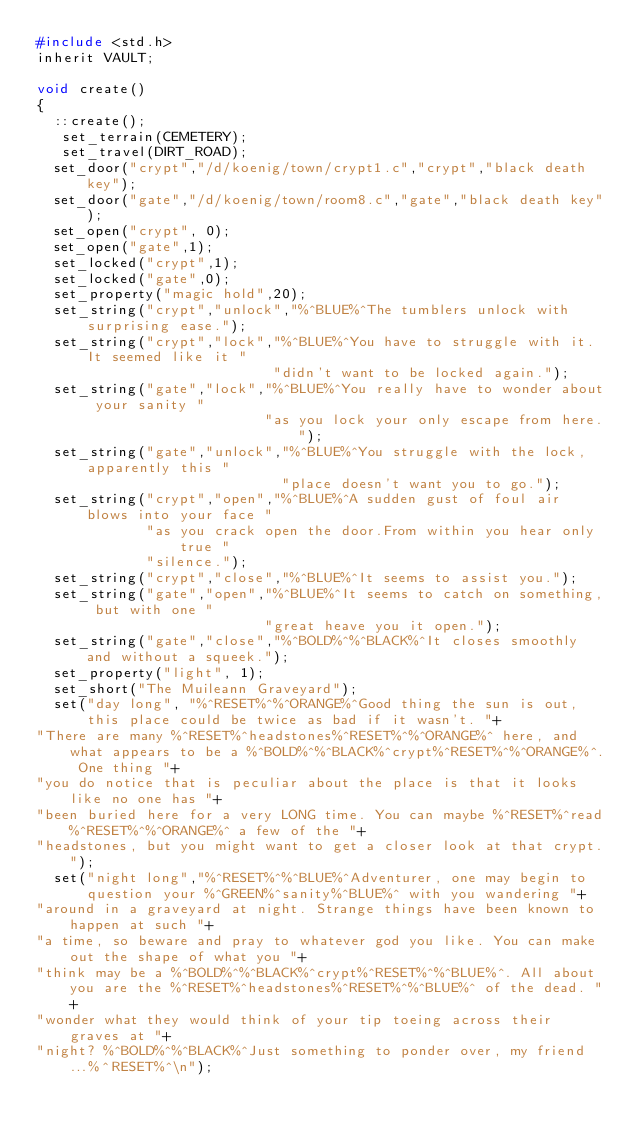Convert code to text. <code><loc_0><loc_0><loc_500><loc_500><_C_>#include <std.h>
inherit VAULT;

void create()
{
  ::create();
   set_terrain(CEMETERY);
   set_travel(DIRT_ROAD);
  set_door("crypt","/d/koenig/town/crypt1.c","crypt","black death key");
  set_door("gate","/d/koenig/town/room8.c","gate","black death key");
  set_open("crypt", 0);
  set_open("gate",1);
  set_locked("crypt",1);
  set_locked("gate",0);
  set_property("magic hold",20);
  set_string("crypt","unlock","%^BLUE%^The tumblers unlock with surprising ease.");
  set_string("crypt","lock","%^BLUE%^You have to struggle with it. It seemed like it "
                            "didn't want to be locked again.");
  set_string("gate","lock","%^BLUE%^You really have to wonder about your sanity "
                           "as you lock your only escape from here.");
  set_string("gate","unlock","%^BLUE%^You struggle with the lock, apparently this "
                             "place doesn't want you to go.");
  set_string("crypt","open","%^BLUE%^A sudden gust of foul air blows into your face "
             "as you crack open the door.From within you hear only true "
             "silence.");
  set_string("crypt","close","%^BLUE%^It seems to assist you.");
  set_string("gate","open","%^BLUE%^It seems to catch on something, but with one "
                           "great heave you it open.");
  set_string("gate","close","%^BOLD%^%^BLACK%^It closes smoothly and without a squeek.");
  set_property("light", 1);
  set_short("The Muileann Graveyard");
  set("day long", "%^RESET%^%^ORANGE%^Good thing the sun is out, this place could be twice as bad if it wasn't. "+
"There are many %^RESET%^headstones%^RESET%^%^ORANGE%^ here, and what appears to be a %^BOLD%^%^BLACK%^crypt%^RESET%^%^ORANGE%^. One thing "+
"you do notice that is peculiar about the place is that it looks like no one has "+
"been buried here for a very LONG time. You can maybe %^RESET%^read%^RESET%^%^ORANGE%^ a few of the "+
"headstones, but you might want to get a closer look at that crypt.");
  set("night long","%^RESET%^%^BLUE%^Adventurer, one may begin to question your %^GREEN%^sanity%^BLUE%^ with you wandering "+
"around in a graveyard at night. Strange things have been known to happen at such "+
"a time, so beware and pray to whatever god you like. You can make out the shape of what you "+
"think may be a %^BOLD%^%^BLACK%^crypt%^RESET%^%^BLUE%^. All about you are the %^RESET%^headstones%^RESET%^%^BLUE%^ of the dead. "+ 
"wonder what they would think of your tip toeing across their graves at "+
"night? %^BOLD%^%^BLACK%^Just something to ponder over, my friend...%^RESET%^\n");</code> 